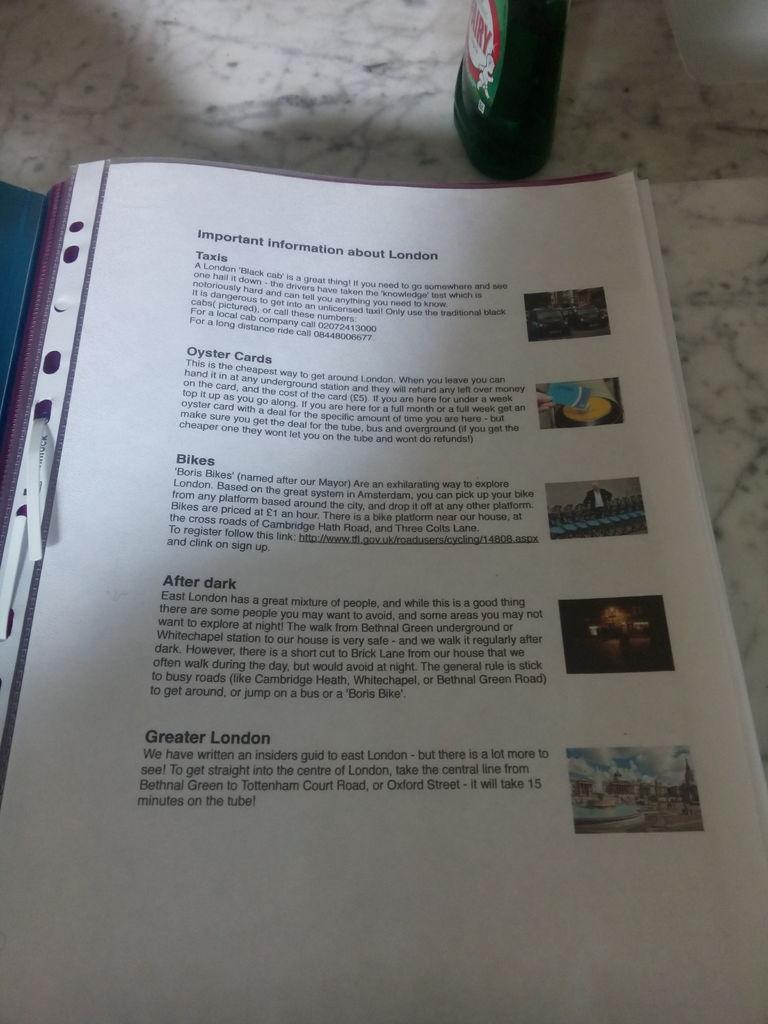What is the city?
Offer a terse response. London. 